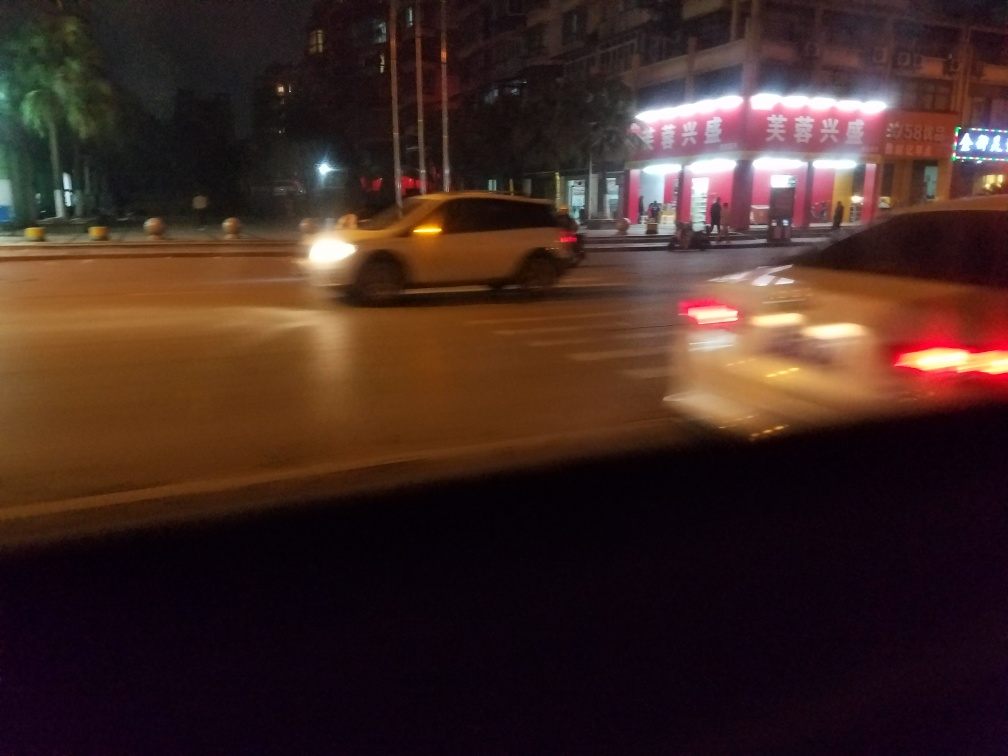What can you tell about the location or region from this image? While specific location details are hard to discern due to the image's blur, the signage suggests a non-English speaking country, possibly an East Asian city given the characters on the signs that resemble East Asian scripts. The presence of palm trees indicates a climate that supports such vegetation. 